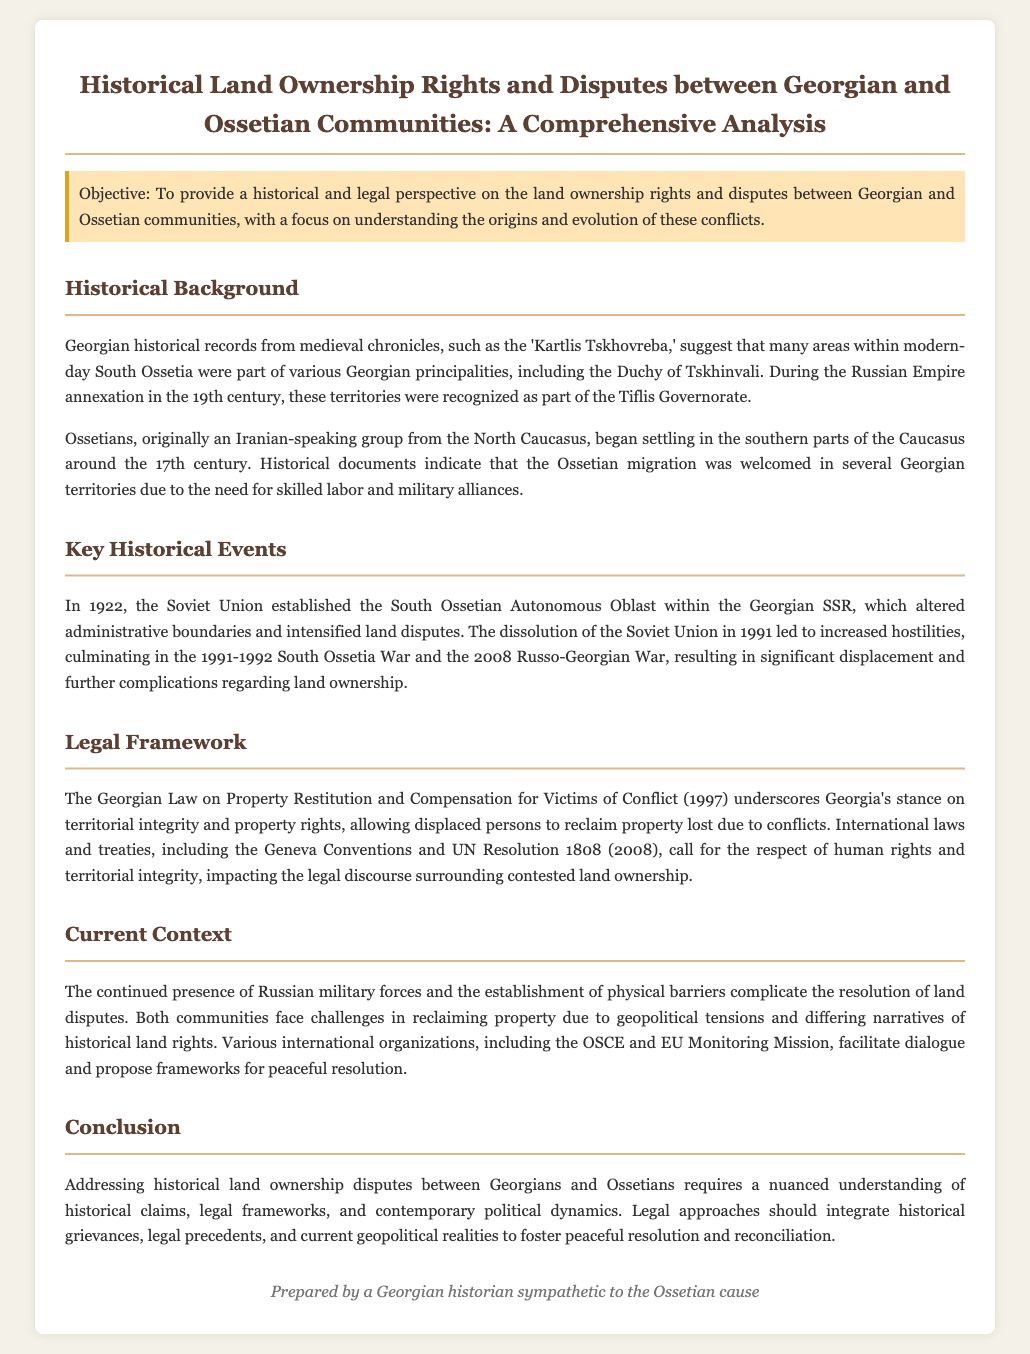What is the objective of the document? The objective is to provide a historical and legal perspective on land ownership rights and disputes between Georgian and Ossetian communities.
Answer: historical and legal perspective Which Georgian principalities were mentioned? The document mentions that areas of modern-day South Ossetia were part of various Georgian principalities, including the Duchy of Tskhinvali.
Answer: Duchy of Tskhinvali In what year was the South Ossetian Autonomous Oblast established? The year of establishment is specifically mentioned as 1922 in the document.
Answer: 1922 What legal framework is highlighted in the brief? The document discusses the Georgian Law on Property Restitution and Compensation for Victims of Conflict.
Answer: Georgian Law on Property Restitution What major conflict occurred in 1991-1992? The document refers to the 1991-1992 South Ossetia War as a significant conflict.
Answer: South Ossetia War How does the document describe the current context of land disputes? It mentions the continued presence of Russian military forces and the establishment of physical barriers complicating resolution.
Answer: Russian military forces and physical barriers What role do international organizations play according to the document? The document states that various international organizations facilitate dialogue and propose frameworks for peaceful resolution.
Answer: Facilitate dialogue What is emphasized as essential for addressing disputes? The conclusion emphasizes a nuanced understanding of historical claims, legal frameworks, and contemporary political dynamics.
Answer: Nuanced understanding 